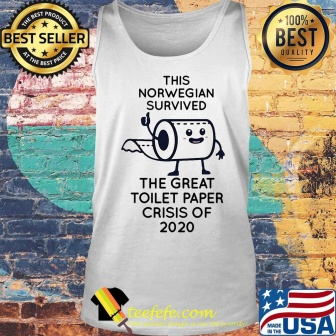Imagine you are a fashion journalist reviewing this tank top. What would you say? As a fashion journalist, I would describe this tank top as both a trendy and nostalgic piece of apparel, cleverly blending humor with cultural commentary. The playful cartoon of a toilet paper roll in a triumphant pose is a creative nod to the resilience and adaptability humans displayed during the 2020 toilet paper shortages. The text 'This Norwegian survived the great toilet paper crisis of 2020' not only makes a humorous statement but also serves as a badge of honor for those who remember the early days of the COVID-19 pandemic. The rustic brick wall backdrop and the presence of the American flag add depth to the image, framing it within a context of both enduring style and patriotism. The additional 'best seller' and '100% best quality' badges emphasize the tank top's high demand and exceptional quality, making it a witty and stylish addition to any wardrobe. This tank top transcends mere fashion, transforming into a wearable piece of history, reminding us of the power of humor to connect and uplift us even in the toughest times. 